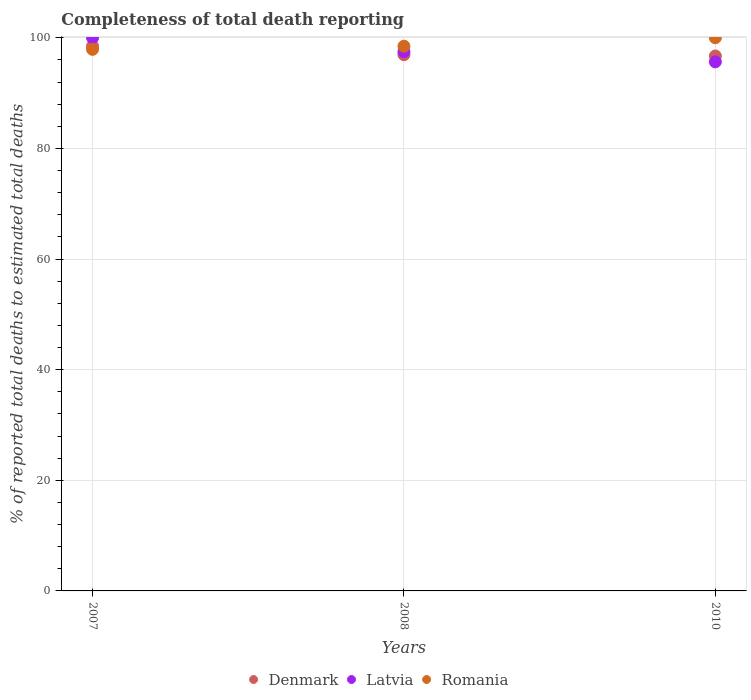How many different coloured dotlines are there?
Make the answer very short. 3. Is the number of dotlines equal to the number of legend labels?
Offer a very short reply. Yes. What is the percentage of total deaths reported in Romania in 2008?
Offer a very short reply. 98.48. Across all years, what is the maximum percentage of total deaths reported in Latvia?
Your response must be concise. 100. Across all years, what is the minimum percentage of total deaths reported in Romania?
Give a very brief answer. 97.91. In which year was the percentage of total deaths reported in Romania maximum?
Give a very brief answer. 2010. In which year was the percentage of total deaths reported in Latvia minimum?
Ensure brevity in your answer.  2010. What is the total percentage of total deaths reported in Romania in the graph?
Provide a short and direct response. 296.39. What is the difference between the percentage of total deaths reported in Denmark in 2008 and that in 2010?
Your answer should be compact. 0.23. What is the difference between the percentage of total deaths reported in Romania in 2010 and the percentage of total deaths reported in Denmark in 2008?
Offer a very short reply. 3.06. What is the average percentage of total deaths reported in Denmark per year?
Your response must be concise. 97.38. In the year 2008, what is the difference between the percentage of total deaths reported in Denmark and percentage of total deaths reported in Romania?
Provide a short and direct response. -1.54. In how many years, is the percentage of total deaths reported in Latvia greater than 72 %?
Keep it short and to the point. 3. What is the ratio of the percentage of total deaths reported in Romania in 2007 to that in 2008?
Offer a terse response. 0.99. Is the difference between the percentage of total deaths reported in Denmark in 2007 and 2010 greater than the difference between the percentage of total deaths reported in Romania in 2007 and 2010?
Provide a short and direct response. Yes. What is the difference between the highest and the second highest percentage of total deaths reported in Latvia?
Your answer should be compact. 2.51. What is the difference between the highest and the lowest percentage of total deaths reported in Denmark?
Offer a terse response. 1.77. Is the sum of the percentage of total deaths reported in Denmark in 2007 and 2008 greater than the maximum percentage of total deaths reported in Romania across all years?
Ensure brevity in your answer.  Yes. Is it the case that in every year, the sum of the percentage of total deaths reported in Latvia and percentage of total deaths reported in Denmark  is greater than the percentage of total deaths reported in Romania?
Provide a succinct answer. Yes. Does the percentage of total deaths reported in Romania monotonically increase over the years?
Your response must be concise. Yes. Is the percentage of total deaths reported in Romania strictly greater than the percentage of total deaths reported in Denmark over the years?
Offer a terse response. No. Is the percentage of total deaths reported in Romania strictly less than the percentage of total deaths reported in Denmark over the years?
Your answer should be compact. No. How many years are there in the graph?
Offer a terse response. 3. What is the difference between two consecutive major ticks on the Y-axis?
Offer a very short reply. 20. Does the graph contain any zero values?
Provide a short and direct response. No. Where does the legend appear in the graph?
Give a very brief answer. Bottom center. How are the legend labels stacked?
Provide a succinct answer. Horizontal. What is the title of the graph?
Ensure brevity in your answer.  Completeness of total death reporting. Does "Liechtenstein" appear as one of the legend labels in the graph?
Make the answer very short. No. What is the label or title of the Y-axis?
Offer a terse response. % of reported total deaths to estimated total deaths. What is the % of reported total deaths to estimated total deaths in Denmark in 2007?
Give a very brief answer. 98.48. What is the % of reported total deaths to estimated total deaths in Latvia in 2007?
Your answer should be compact. 100. What is the % of reported total deaths to estimated total deaths of Romania in 2007?
Keep it short and to the point. 97.91. What is the % of reported total deaths to estimated total deaths in Denmark in 2008?
Ensure brevity in your answer.  96.94. What is the % of reported total deaths to estimated total deaths in Latvia in 2008?
Your answer should be very brief. 97.49. What is the % of reported total deaths to estimated total deaths in Romania in 2008?
Give a very brief answer. 98.48. What is the % of reported total deaths to estimated total deaths of Denmark in 2010?
Provide a succinct answer. 96.71. What is the % of reported total deaths to estimated total deaths of Latvia in 2010?
Your answer should be compact. 95.65. Across all years, what is the maximum % of reported total deaths to estimated total deaths in Denmark?
Your answer should be compact. 98.48. Across all years, what is the maximum % of reported total deaths to estimated total deaths of Latvia?
Provide a short and direct response. 100. Across all years, what is the minimum % of reported total deaths to estimated total deaths of Denmark?
Keep it short and to the point. 96.71. Across all years, what is the minimum % of reported total deaths to estimated total deaths of Latvia?
Keep it short and to the point. 95.65. Across all years, what is the minimum % of reported total deaths to estimated total deaths of Romania?
Keep it short and to the point. 97.91. What is the total % of reported total deaths to estimated total deaths of Denmark in the graph?
Your answer should be very brief. 292.13. What is the total % of reported total deaths to estimated total deaths of Latvia in the graph?
Your answer should be very brief. 293.14. What is the total % of reported total deaths to estimated total deaths in Romania in the graph?
Your response must be concise. 296.39. What is the difference between the % of reported total deaths to estimated total deaths in Denmark in 2007 and that in 2008?
Offer a very short reply. 1.53. What is the difference between the % of reported total deaths to estimated total deaths of Latvia in 2007 and that in 2008?
Give a very brief answer. 2.51. What is the difference between the % of reported total deaths to estimated total deaths in Romania in 2007 and that in 2008?
Keep it short and to the point. -0.57. What is the difference between the % of reported total deaths to estimated total deaths in Denmark in 2007 and that in 2010?
Keep it short and to the point. 1.77. What is the difference between the % of reported total deaths to estimated total deaths in Latvia in 2007 and that in 2010?
Offer a terse response. 4.35. What is the difference between the % of reported total deaths to estimated total deaths of Romania in 2007 and that in 2010?
Your answer should be compact. -2.09. What is the difference between the % of reported total deaths to estimated total deaths of Denmark in 2008 and that in 2010?
Your response must be concise. 0.23. What is the difference between the % of reported total deaths to estimated total deaths of Latvia in 2008 and that in 2010?
Make the answer very short. 1.84. What is the difference between the % of reported total deaths to estimated total deaths in Romania in 2008 and that in 2010?
Give a very brief answer. -1.52. What is the difference between the % of reported total deaths to estimated total deaths in Denmark in 2007 and the % of reported total deaths to estimated total deaths in Latvia in 2008?
Make the answer very short. 0.99. What is the difference between the % of reported total deaths to estimated total deaths in Denmark in 2007 and the % of reported total deaths to estimated total deaths in Romania in 2008?
Offer a terse response. -0. What is the difference between the % of reported total deaths to estimated total deaths in Latvia in 2007 and the % of reported total deaths to estimated total deaths in Romania in 2008?
Provide a short and direct response. 1.52. What is the difference between the % of reported total deaths to estimated total deaths in Denmark in 2007 and the % of reported total deaths to estimated total deaths in Latvia in 2010?
Make the answer very short. 2.83. What is the difference between the % of reported total deaths to estimated total deaths in Denmark in 2007 and the % of reported total deaths to estimated total deaths in Romania in 2010?
Your answer should be compact. -1.52. What is the difference between the % of reported total deaths to estimated total deaths of Denmark in 2008 and the % of reported total deaths to estimated total deaths of Latvia in 2010?
Your answer should be compact. 1.29. What is the difference between the % of reported total deaths to estimated total deaths in Denmark in 2008 and the % of reported total deaths to estimated total deaths in Romania in 2010?
Keep it short and to the point. -3.06. What is the difference between the % of reported total deaths to estimated total deaths in Latvia in 2008 and the % of reported total deaths to estimated total deaths in Romania in 2010?
Keep it short and to the point. -2.51. What is the average % of reported total deaths to estimated total deaths in Denmark per year?
Your answer should be compact. 97.38. What is the average % of reported total deaths to estimated total deaths of Latvia per year?
Your answer should be compact. 97.71. What is the average % of reported total deaths to estimated total deaths in Romania per year?
Give a very brief answer. 98.8. In the year 2007, what is the difference between the % of reported total deaths to estimated total deaths in Denmark and % of reported total deaths to estimated total deaths in Latvia?
Provide a succinct answer. -1.52. In the year 2007, what is the difference between the % of reported total deaths to estimated total deaths in Denmark and % of reported total deaths to estimated total deaths in Romania?
Your answer should be compact. 0.57. In the year 2007, what is the difference between the % of reported total deaths to estimated total deaths in Latvia and % of reported total deaths to estimated total deaths in Romania?
Provide a succinct answer. 2.09. In the year 2008, what is the difference between the % of reported total deaths to estimated total deaths of Denmark and % of reported total deaths to estimated total deaths of Latvia?
Your response must be concise. -0.55. In the year 2008, what is the difference between the % of reported total deaths to estimated total deaths in Denmark and % of reported total deaths to estimated total deaths in Romania?
Ensure brevity in your answer.  -1.54. In the year 2008, what is the difference between the % of reported total deaths to estimated total deaths of Latvia and % of reported total deaths to estimated total deaths of Romania?
Ensure brevity in your answer.  -0.99. In the year 2010, what is the difference between the % of reported total deaths to estimated total deaths in Denmark and % of reported total deaths to estimated total deaths in Latvia?
Your answer should be very brief. 1.06. In the year 2010, what is the difference between the % of reported total deaths to estimated total deaths in Denmark and % of reported total deaths to estimated total deaths in Romania?
Your response must be concise. -3.29. In the year 2010, what is the difference between the % of reported total deaths to estimated total deaths of Latvia and % of reported total deaths to estimated total deaths of Romania?
Keep it short and to the point. -4.35. What is the ratio of the % of reported total deaths to estimated total deaths of Denmark in 2007 to that in 2008?
Make the answer very short. 1.02. What is the ratio of the % of reported total deaths to estimated total deaths of Latvia in 2007 to that in 2008?
Your answer should be very brief. 1.03. What is the ratio of the % of reported total deaths to estimated total deaths in Denmark in 2007 to that in 2010?
Ensure brevity in your answer.  1.02. What is the ratio of the % of reported total deaths to estimated total deaths of Latvia in 2007 to that in 2010?
Offer a very short reply. 1.05. What is the ratio of the % of reported total deaths to estimated total deaths in Romania in 2007 to that in 2010?
Make the answer very short. 0.98. What is the ratio of the % of reported total deaths to estimated total deaths in Denmark in 2008 to that in 2010?
Keep it short and to the point. 1. What is the ratio of the % of reported total deaths to estimated total deaths in Latvia in 2008 to that in 2010?
Provide a short and direct response. 1.02. What is the difference between the highest and the second highest % of reported total deaths to estimated total deaths of Denmark?
Your answer should be very brief. 1.53. What is the difference between the highest and the second highest % of reported total deaths to estimated total deaths in Latvia?
Your response must be concise. 2.51. What is the difference between the highest and the second highest % of reported total deaths to estimated total deaths in Romania?
Keep it short and to the point. 1.52. What is the difference between the highest and the lowest % of reported total deaths to estimated total deaths in Denmark?
Provide a succinct answer. 1.77. What is the difference between the highest and the lowest % of reported total deaths to estimated total deaths in Latvia?
Your response must be concise. 4.35. What is the difference between the highest and the lowest % of reported total deaths to estimated total deaths of Romania?
Keep it short and to the point. 2.09. 